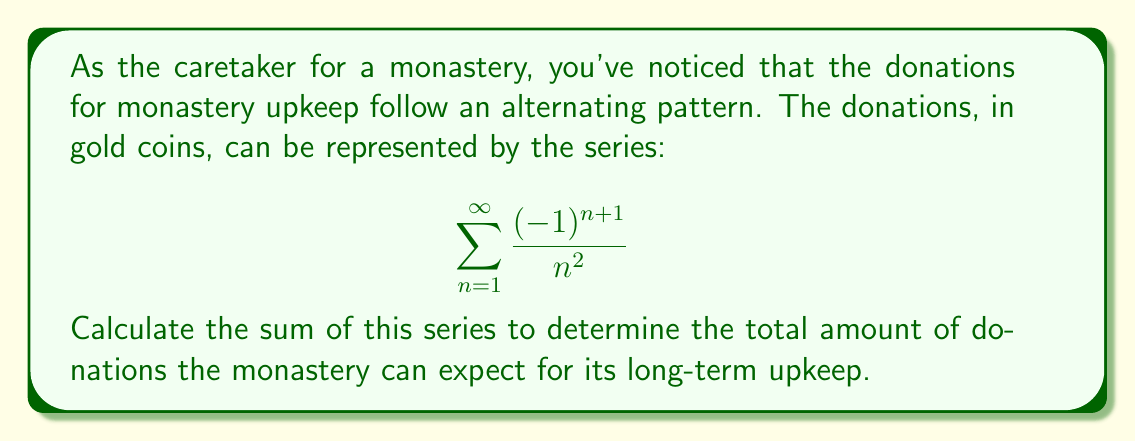Can you answer this question? To solve this problem, we need to recognize that this is an alternating series. Specifically, it's the alternating p-series where p = 2. The general form of this series is:

$$\sum_{n=1}^{\infty} \frac{(-1)^{n+1}}{n^p}$$

For p > 1, this series converges, and its sum is given by the formula:

$$\sum_{n=1}^{\infty} \frac{(-1)^{n+1}}{n^p} = (1-2^{1-p})\zeta(p)$$

Where $\zeta(p)$ is the Riemann zeta function.

In our case, p = 2, so we have:

$$\sum_{n=1}^{\infty} \frac{(-1)^{n+1}}{n^2} = (1-2^{1-2})\zeta(2)$$

We know that $\zeta(2) = \frac{\pi^2}{6}$, so:

$$\sum_{n=1}^{\infty} \frac{(-1)^{n+1}}{n^2} = (1-\frac{1}{2})\frac{\pi^2}{6}$$

$$= \frac{1}{2} \cdot \frac{\pi^2}{6}$$

$$= \frac{\pi^2}{12}$$

Therefore, the sum of the series is $\frac{\pi^2}{12}$.
Answer: $\frac{\pi^2}{12}$ gold coins 